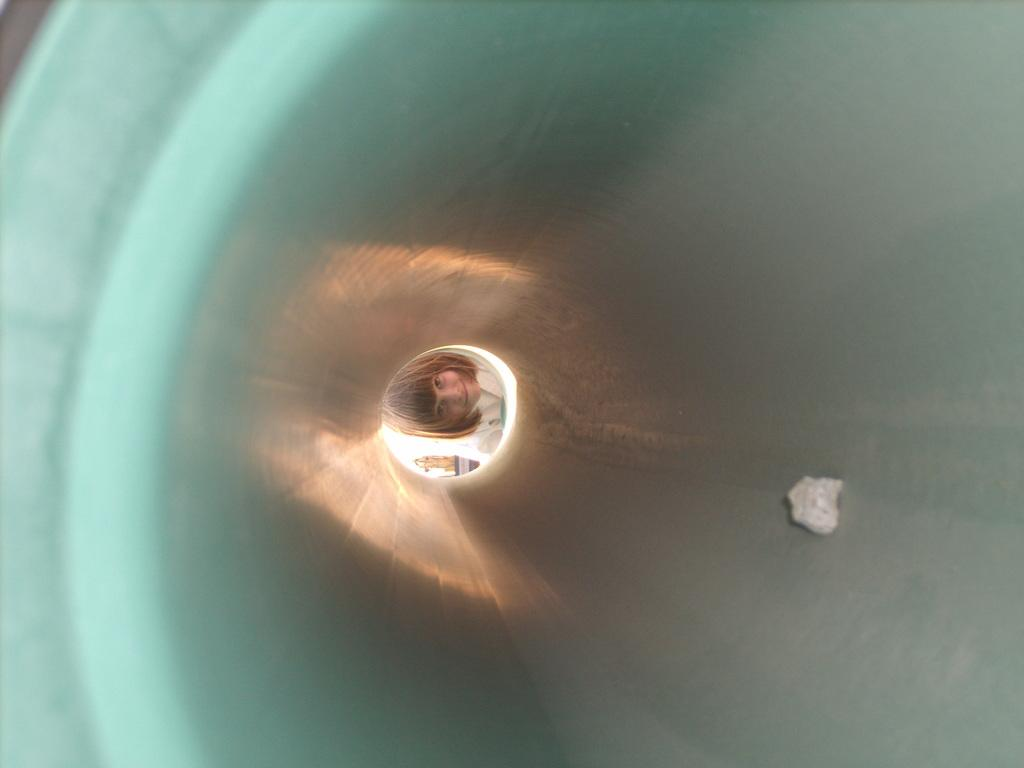What is the main subject in the center of the image? There is a child in the center of the image. What object can be seen in the image besides the child? There is a crushed paper in the image. Where is the crushed paper located in the image? The crushed paper is inside a tunnel. What type of cabbage is hanging from the lamp in the image? There is no cabbage or lamp present in the image, so this question cannot be answered. 